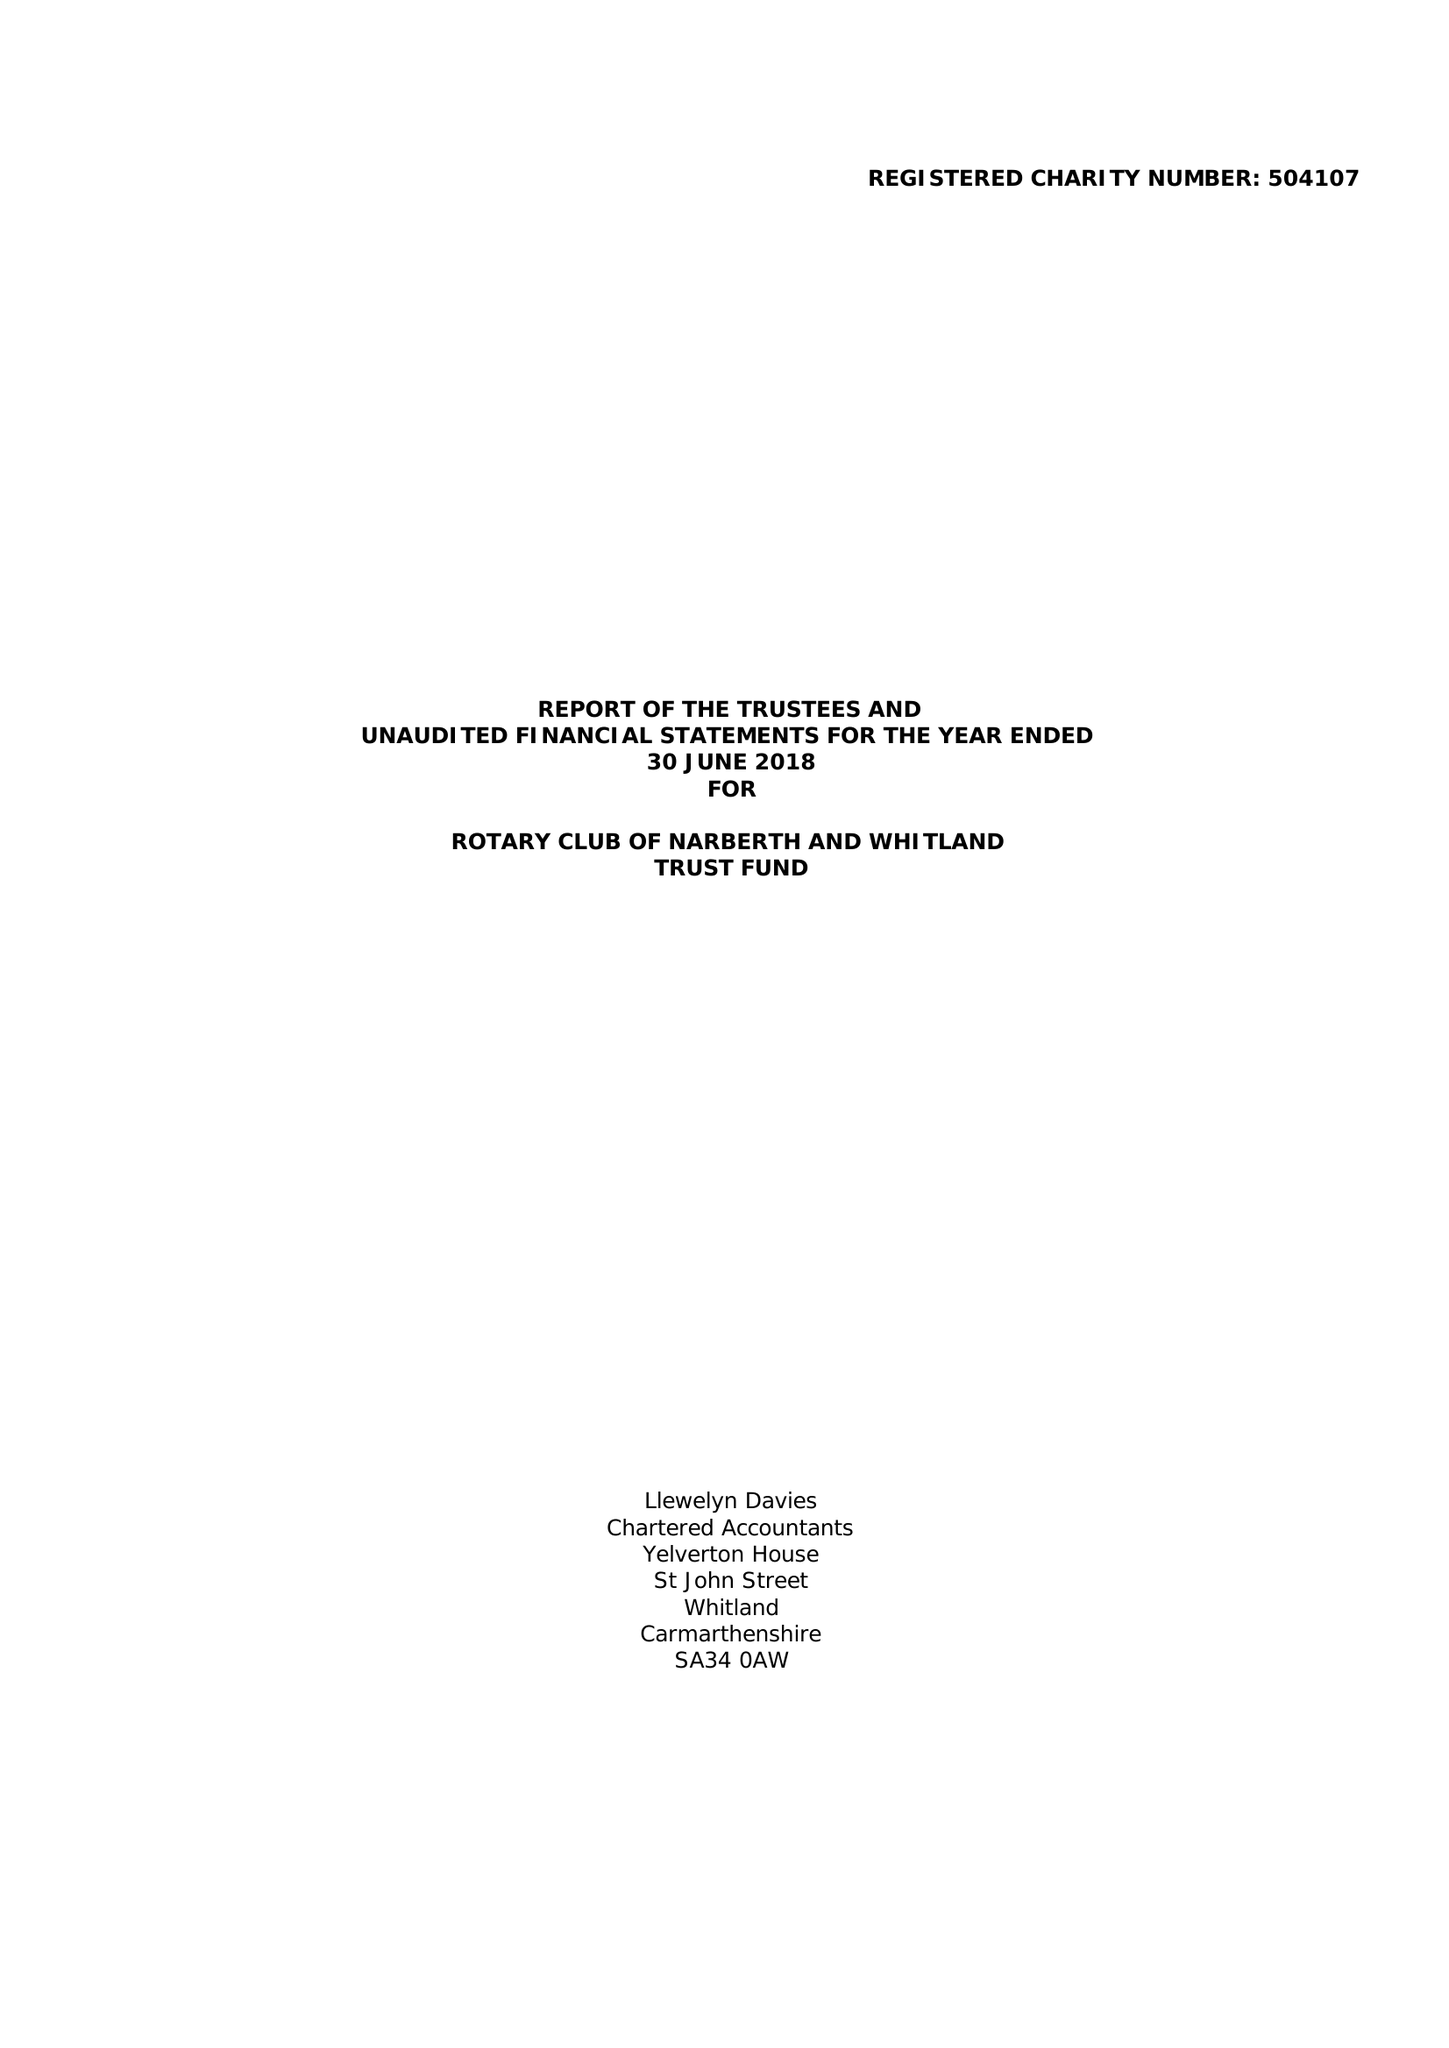What is the value for the address__postcode?
Answer the question using a single word or phrase. SA67 8RP 